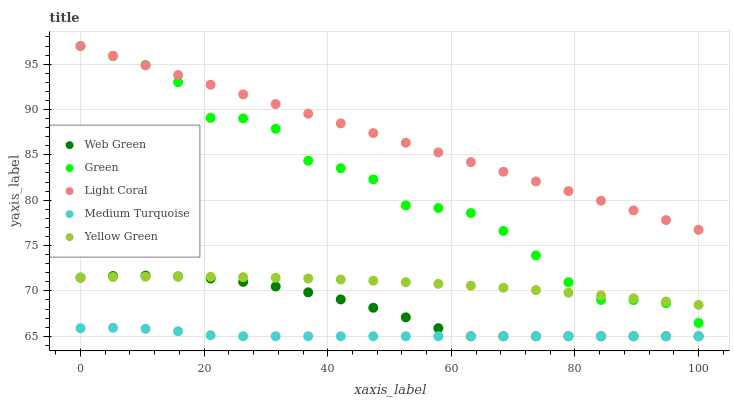Does Medium Turquoise have the minimum area under the curve?
Answer yes or no. Yes. Does Light Coral have the maximum area under the curve?
Answer yes or no. Yes. Does Green have the minimum area under the curve?
Answer yes or no. No. Does Green have the maximum area under the curve?
Answer yes or no. No. Is Light Coral the smoothest?
Answer yes or no. Yes. Is Green the roughest?
Answer yes or no. Yes. Is Medium Turquoise the smoothest?
Answer yes or no. No. Is Medium Turquoise the roughest?
Answer yes or no. No. Does Medium Turquoise have the lowest value?
Answer yes or no. Yes. Does Green have the lowest value?
Answer yes or no. No. Does Green have the highest value?
Answer yes or no. Yes. Does Medium Turquoise have the highest value?
Answer yes or no. No. Is Medium Turquoise less than Light Coral?
Answer yes or no. Yes. Is Green greater than Web Green?
Answer yes or no. Yes. Does Light Coral intersect Green?
Answer yes or no. Yes. Is Light Coral less than Green?
Answer yes or no. No. Is Light Coral greater than Green?
Answer yes or no. No. Does Medium Turquoise intersect Light Coral?
Answer yes or no. No. 